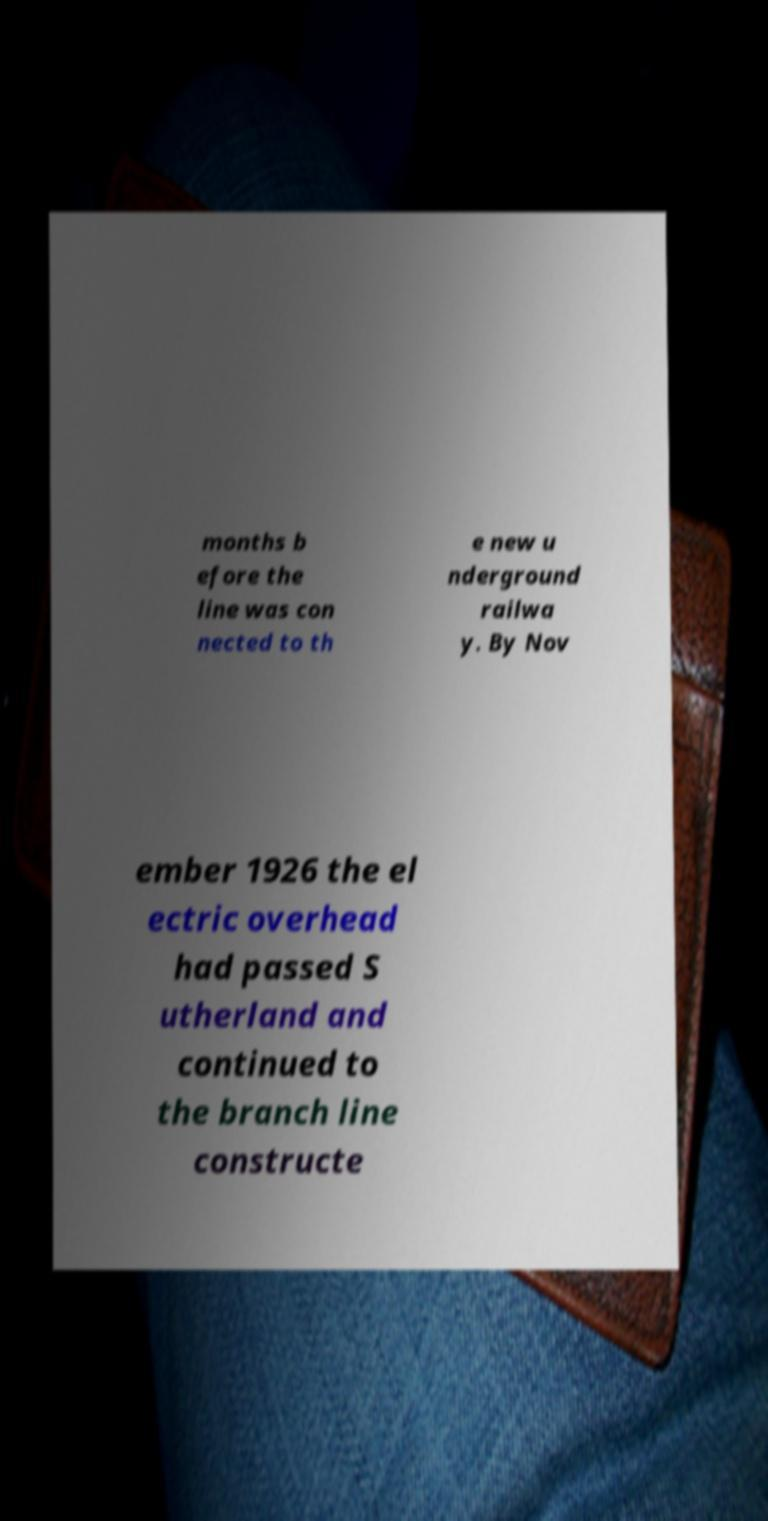I need the written content from this picture converted into text. Can you do that? months b efore the line was con nected to th e new u nderground railwa y. By Nov ember 1926 the el ectric overhead had passed S utherland and continued to the branch line constructe 